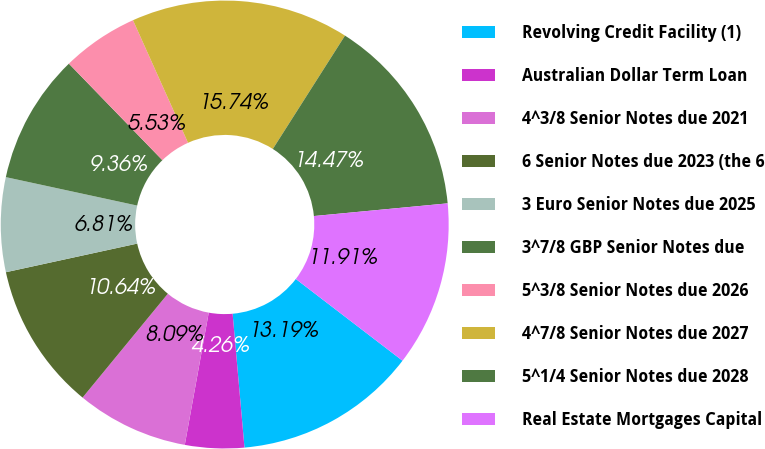Convert chart to OTSL. <chart><loc_0><loc_0><loc_500><loc_500><pie_chart><fcel>Revolving Credit Facility (1)<fcel>Australian Dollar Term Loan<fcel>4^3/8 Senior Notes due 2021<fcel>6 Senior Notes due 2023 (the 6<fcel>3 Euro Senior Notes due 2025<fcel>3^7/8 GBP Senior Notes due<fcel>5^3/8 Senior Notes due 2026<fcel>4^7/8 Senior Notes due 2027<fcel>5^1/4 Senior Notes due 2028<fcel>Real Estate Mortgages Capital<nl><fcel>13.19%<fcel>4.26%<fcel>8.09%<fcel>10.64%<fcel>6.81%<fcel>9.36%<fcel>5.53%<fcel>15.74%<fcel>14.47%<fcel>11.91%<nl></chart> 